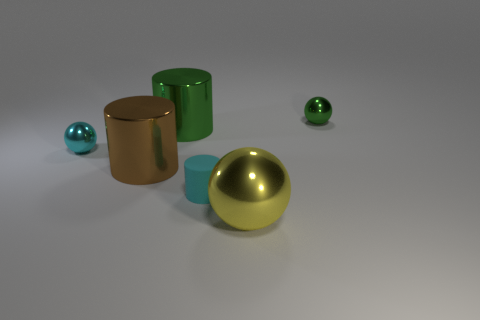Can you describe the composition of the objects in this scene? Certainly, the scene comprises a collection of geometric shapes positioned on a flat surface. There are two cylinders, one larger, matte, and cyan in color, and the other smaller with a shiny golden finish. A large shiny gold ball sits prominently in the foreground, while a smaller ball with a similar sheen but in teal is present in the background. The setup creates a study of shapes, colors, and materials and their interaction with light. 